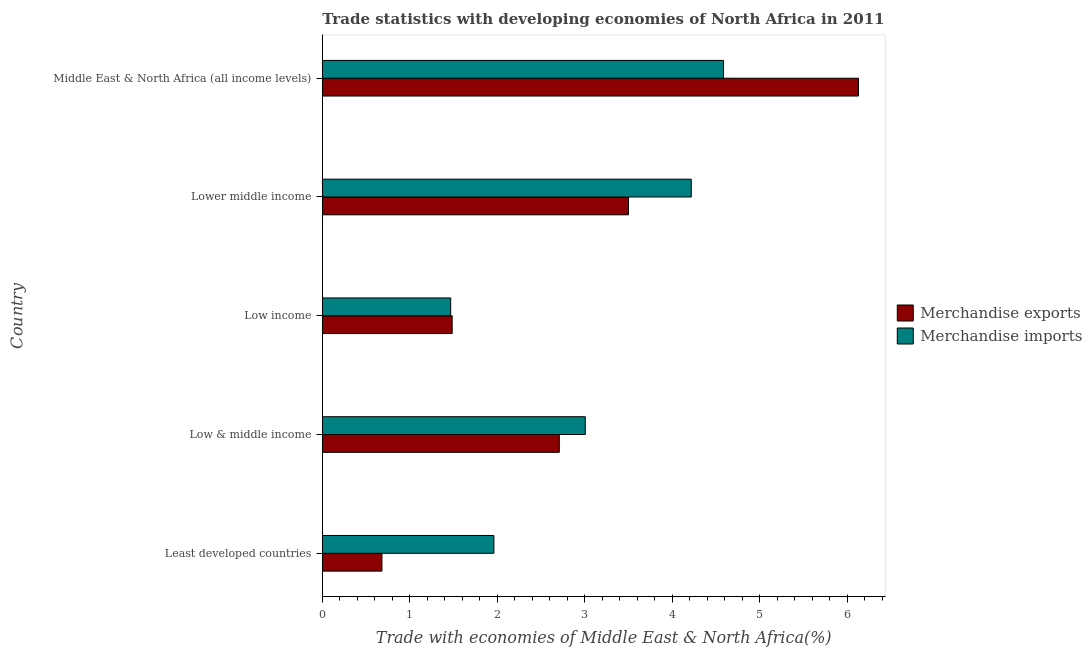How many groups of bars are there?
Ensure brevity in your answer.  5. Are the number of bars on each tick of the Y-axis equal?
Offer a terse response. Yes. How many bars are there on the 3rd tick from the top?
Your response must be concise. 2. How many bars are there on the 3rd tick from the bottom?
Your answer should be very brief. 2. What is the label of the 5th group of bars from the top?
Your answer should be compact. Least developed countries. In how many cases, is the number of bars for a given country not equal to the number of legend labels?
Provide a succinct answer. 0. What is the merchandise imports in Least developed countries?
Keep it short and to the point. 1.96. Across all countries, what is the maximum merchandise exports?
Keep it short and to the point. 6.13. Across all countries, what is the minimum merchandise imports?
Provide a succinct answer. 1.47. In which country was the merchandise exports maximum?
Offer a very short reply. Middle East & North Africa (all income levels). In which country was the merchandise exports minimum?
Your answer should be compact. Least developed countries. What is the total merchandise exports in the graph?
Give a very brief answer. 14.5. What is the difference between the merchandise imports in Least developed countries and that in Lower middle income?
Offer a terse response. -2.26. What is the difference between the merchandise imports in Low & middle income and the merchandise exports in Middle East & North Africa (all income levels)?
Your answer should be very brief. -3.12. What is the average merchandise exports per country?
Your answer should be compact. 2.9. What is the difference between the merchandise imports and merchandise exports in Low income?
Make the answer very short. -0.02. What is the ratio of the merchandise imports in Low & middle income to that in Low income?
Your response must be concise. 2.05. Is the difference between the merchandise exports in Least developed countries and Middle East & North Africa (all income levels) greater than the difference between the merchandise imports in Least developed countries and Middle East & North Africa (all income levels)?
Your answer should be very brief. No. What is the difference between the highest and the second highest merchandise imports?
Ensure brevity in your answer.  0.37. What is the difference between the highest and the lowest merchandise imports?
Offer a very short reply. 3.12. What does the 2nd bar from the bottom in Least developed countries represents?
Offer a very short reply. Merchandise imports. Are all the bars in the graph horizontal?
Your answer should be compact. Yes. What is the difference between two consecutive major ticks on the X-axis?
Provide a succinct answer. 1. How many legend labels are there?
Offer a terse response. 2. How are the legend labels stacked?
Your response must be concise. Vertical. What is the title of the graph?
Your answer should be compact. Trade statistics with developing economies of North Africa in 2011. Does "Secondary Education" appear as one of the legend labels in the graph?
Ensure brevity in your answer.  No. What is the label or title of the X-axis?
Give a very brief answer. Trade with economies of Middle East & North Africa(%). What is the label or title of the Y-axis?
Your response must be concise. Country. What is the Trade with economies of Middle East & North Africa(%) in Merchandise exports in Least developed countries?
Provide a succinct answer. 0.68. What is the Trade with economies of Middle East & North Africa(%) of Merchandise imports in Least developed countries?
Keep it short and to the point. 1.96. What is the Trade with economies of Middle East & North Africa(%) in Merchandise exports in Low & middle income?
Ensure brevity in your answer.  2.71. What is the Trade with economies of Middle East & North Africa(%) in Merchandise imports in Low & middle income?
Keep it short and to the point. 3.01. What is the Trade with economies of Middle East & North Africa(%) of Merchandise exports in Low income?
Give a very brief answer. 1.48. What is the Trade with economies of Middle East & North Africa(%) of Merchandise imports in Low income?
Your answer should be compact. 1.47. What is the Trade with economies of Middle East & North Africa(%) in Merchandise exports in Lower middle income?
Provide a succinct answer. 3.5. What is the Trade with economies of Middle East & North Africa(%) of Merchandise imports in Lower middle income?
Give a very brief answer. 4.22. What is the Trade with economies of Middle East & North Africa(%) in Merchandise exports in Middle East & North Africa (all income levels)?
Offer a terse response. 6.13. What is the Trade with economies of Middle East & North Africa(%) of Merchandise imports in Middle East & North Africa (all income levels)?
Make the answer very short. 4.59. Across all countries, what is the maximum Trade with economies of Middle East & North Africa(%) in Merchandise exports?
Your answer should be very brief. 6.13. Across all countries, what is the maximum Trade with economies of Middle East & North Africa(%) in Merchandise imports?
Offer a very short reply. 4.59. Across all countries, what is the minimum Trade with economies of Middle East & North Africa(%) of Merchandise exports?
Ensure brevity in your answer.  0.68. Across all countries, what is the minimum Trade with economies of Middle East & North Africa(%) in Merchandise imports?
Offer a terse response. 1.47. What is the total Trade with economies of Middle East & North Africa(%) in Merchandise exports in the graph?
Your answer should be very brief. 14.5. What is the total Trade with economies of Middle East & North Africa(%) in Merchandise imports in the graph?
Offer a terse response. 15.24. What is the difference between the Trade with economies of Middle East & North Africa(%) in Merchandise exports in Least developed countries and that in Low & middle income?
Keep it short and to the point. -2.03. What is the difference between the Trade with economies of Middle East & North Africa(%) of Merchandise imports in Least developed countries and that in Low & middle income?
Your answer should be compact. -1.04. What is the difference between the Trade with economies of Middle East & North Africa(%) of Merchandise exports in Least developed countries and that in Low income?
Provide a succinct answer. -0.8. What is the difference between the Trade with economies of Middle East & North Africa(%) in Merchandise imports in Least developed countries and that in Low income?
Your response must be concise. 0.49. What is the difference between the Trade with economies of Middle East & North Africa(%) of Merchandise exports in Least developed countries and that in Lower middle income?
Keep it short and to the point. -2.82. What is the difference between the Trade with economies of Middle East & North Africa(%) in Merchandise imports in Least developed countries and that in Lower middle income?
Give a very brief answer. -2.26. What is the difference between the Trade with economies of Middle East & North Africa(%) in Merchandise exports in Least developed countries and that in Middle East & North Africa (all income levels)?
Offer a terse response. -5.45. What is the difference between the Trade with economies of Middle East & North Africa(%) in Merchandise imports in Least developed countries and that in Middle East & North Africa (all income levels)?
Offer a terse response. -2.62. What is the difference between the Trade with economies of Middle East & North Africa(%) of Merchandise exports in Low & middle income and that in Low income?
Your answer should be very brief. 1.22. What is the difference between the Trade with economies of Middle East & North Africa(%) of Merchandise imports in Low & middle income and that in Low income?
Provide a succinct answer. 1.54. What is the difference between the Trade with economies of Middle East & North Africa(%) in Merchandise exports in Low & middle income and that in Lower middle income?
Keep it short and to the point. -0.79. What is the difference between the Trade with economies of Middle East & North Africa(%) of Merchandise imports in Low & middle income and that in Lower middle income?
Your response must be concise. -1.21. What is the difference between the Trade with economies of Middle East & North Africa(%) in Merchandise exports in Low & middle income and that in Middle East & North Africa (all income levels)?
Ensure brevity in your answer.  -3.42. What is the difference between the Trade with economies of Middle East & North Africa(%) in Merchandise imports in Low & middle income and that in Middle East & North Africa (all income levels)?
Offer a terse response. -1.58. What is the difference between the Trade with economies of Middle East & North Africa(%) of Merchandise exports in Low income and that in Lower middle income?
Offer a terse response. -2.02. What is the difference between the Trade with economies of Middle East & North Africa(%) of Merchandise imports in Low income and that in Lower middle income?
Ensure brevity in your answer.  -2.75. What is the difference between the Trade with economies of Middle East & North Africa(%) of Merchandise exports in Low income and that in Middle East & North Africa (all income levels)?
Ensure brevity in your answer.  -4.64. What is the difference between the Trade with economies of Middle East & North Africa(%) in Merchandise imports in Low income and that in Middle East & North Africa (all income levels)?
Your response must be concise. -3.12. What is the difference between the Trade with economies of Middle East & North Africa(%) in Merchandise exports in Lower middle income and that in Middle East & North Africa (all income levels)?
Your response must be concise. -2.63. What is the difference between the Trade with economies of Middle East & North Africa(%) in Merchandise imports in Lower middle income and that in Middle East & North Africa (all income levels)?
Give a very brief answer. -0.37. What is the difference between the Trade with economies of Middle East & North Africa(%) in Merchandise exports in Least developed countries and the Trade with economies of Middle East & North Africa(%) in Merchandise imports in Low & middle income?
Your answer should be very brief. -2.32. What is the difference between the Trade with economies of Middle East & North Africa(%) of Merchandise exports in Least developed countries and the Trade with economies of Middle East & North Africa(%) of Merchandise imports in Low income?
Offer a very short reply. -0.79. What is the difference between the Trade with economies of Middle East & North Africa(%) in Merchandise exports in Least developed countries and the Trade with economies of Middle East & North Africa(%) in Merchandise imports in Lower middle income?
Offer a very short reply. -3.54. What is the difference between the Trade with economies of Middle East & North Africa(%) in Merchandise exports in Least developed countries and the Trade with economies of Middle East & North Africa(%) in Merchandise imports in Middle East & North Africa (all income levels)?
Your answer should be very brief. -3.9. What is the difference between the Trade with economies of Middle East & North Africa(%) of Merchandise exports in Low & middle income and the Trade with economies of Middle East & North Africa(%) of Merchandise imports in Low income?
Offer a terse response. 1.24. What is the difference between the Trade with economies of Middle East & North Africa(%) in Merchandise exports in Low & middle income and the Trade with economies of Middle East & North Africa(%) in Merchandise imports in Lower middle income?
Your answer should be compact. -1.51. What is the difference between the Trade with economies of Middle East & North Africa(%) of Merchandise exports in Low & middle income and the Trade with economies of Middle East & North Africa(%) of Merchandise imports in Middle East & North Africa (all income levels)?
Offer a terse response. -1.88. What is the difference between the Trade with economies of Middle East & North Africa(%) in Merchandise exports in Low income and the Trade with economies of Middle East & North Africa(%) in Merchandise imports in Lower middle income?
Offer a terse response. -2.73. What is the difference between the Trade with economies of Middle East & North Africa(%) of Merchandise exports in Low income and the Trade with economies of Middle East & North Africa(%) of Merchandise imports in Middle East & North Africa (all income levels)?
Ensure brevity in your answer.  -3.1. What is the difference between the Trade with economies of Middle East & North Africa(%) of Merchandise exports in Lower middle income and the Trade with economies of Middle East & North Africa(%) of Merchandise imports in Middle East & North Africa (all income levels)?
Keep it short and to the point. -1.09. What is the average Trade with economies of Middle East & North Africa(%) of Merchandise exports per country?
Ensure brevity in your answer.  2.9. What is the average Trade with economies of Middle East & North Africa(%) of Merchandise imports per country?
Ensure brevity in your answer.  3.05. What is the difference between the Trade with economies of Middle East & North Africa(%) in Merchandise exports and Trade with economies of Middle East & North Africa(%) in Merchandise imports in Least developed countries?
Offer a terse response. -1.28. What is the difference between the Trade with economies of Middle East & North Africa(%) of Merchandise exports and Trade with economies of Middle East & North Africa(%) of Merchandise imports in Low & middle income?
Ensure brevity in your answer.  -0.3. What is the difference between the Trade with economies of Middle East & North Africa(%) in Merchandise exports and Trade with economies of Middle East & North Africa(%) in Merchandise imports in Low income?
Your response must be concise. 0.02. What is the difference between the Trade with economies of Middle East & North Africa(%) of Merchandise exports and Trade with economies of Middle East & North Africa(%) of Merchandise imports in Lower middle income?
Your answer should be compact. -0.72. What is the difference between the Trade with economies of Middle East & North Africa(%) of Merchandise exports and Trade with economies of Middle East & North Africa(%) of Merchandise imports in Middle East & North Africa (all income levels)?
Keep it short and to the point. 1.54. What is the ratio of the Trade with economies of Middle East & North Africa(%) in Merchandise exports in Least developed countries to that in Low & middle income?
Ensure brevity in your answer.  0.25. What is the ratio of the Trade with economies of Middle East & North Africa(%) in Merchandise imports in Least developed countries to that in Low & middle income?
Make the answer very short. 0.65. What is the ratio of the Trade with economies of Middle East & North Africa(%) of Merchandise exports in Least developed countries to that in Low income?
Make the answer very short. 0.46. What is the ratio of the Trade with economies of Middle East & North Africa(%) of Merchandise imports in Least developed countries to that in Low income?
Offer a very short reply. 1.34. What is the ratio of the Trade with economies of Middle East & North Africa(%) in Merchandise exports in Least developed countries to that in Lower middle income?
Your answer should be very brief. 0.19. What is the ratio of the Trade with economies of Middle East & North Africa(%) of Merchandise imports in Least developed countries to that in Lower middle income?
Offer a very short reply. 0.47. What is the ratio of the Trade with economies of Middle East & North Africa(%) in Merchandise exports in Least developed countries to that in Middle East & North Africa (all income levels)?
Provide a succinct answer. 0.11. What is the ratio of the Trade with economies of Middle East & North Africa(%) of Merchandise imports in Least developed countries to that in Middle East & North Africa (all income levels)?
Your response must be concise. 0.43. What is the ratio of the Trade with economies of Middle East & North Africa(%) in Merchandise exports in Low & middle income to that in Low income?
Make the answer very short. 1.83. What is the ratio of the Trade with economies of Middle East & North Africa(%) in Merchandise imports in Low & middle income to that in Low income?
Your response must be concise. 2.05. What is the ratio of the Trade with economies of Middle East & North Africa(%) in Merchandise exports in Low & middle income to that in Lower middle income?
Offer a terse response. 0.77. What is the ratio of the Trade with economies of Middle East & North Africa(%) in Merchandise imports in Low & middle income to that in Lower middle income?
Your answer should be very brief. 0.71. What is the ratio of the Trade with economies of Middle East & North Africa(%) of Merchandise exports in Low & middle income to that in Middle East & North Africa (all income levels)?
Provide a succinct answer. 0.44. What is the ratio of the Trade with economies of Middle East & North Africa(%) in Merchandise imports in Low & middle income to that in Middle East & North Africa (all income levels)?
Offer a very short reply. 0.66. What is the ratio of the Trade with economies of Middle East & North Africa(%) of Merchandise exports in Low income to that in Lower middle income?
Provide a short and direct response. 0.42. What is the ratio of the Trade with economies of Middle East & North Africa(%) of Merchandise imports in Low income to that in Lower middle income?
Provide a succinct answer. 0.35. What is the ratio of the Trade with economies of Middle East & North Africa(%) of Merchandise exports in Low income to that in Middle East & North Africa (all income levels)?
Give a very brief answer. 0.24. What is the ratio of the Trade with economies of Middle East & North Africa(%) of Merchandise imports in Low income to that in Middle East & North Africa (all income levels)?
Give a very brief answer. 0.32. What is the ratio of the Trade with economies of Middle East & North Africa(%) of Merchandise exports in Lower middle income to that in Middle East & North Africa (all income levels)?
Offer a terse response. 0.57. What is the ratio of the Trade with economies of Middle East & North Africa(%) of Merchandise imports in Lower middle income to that in Middle East & North Africa (all income levels)?
Make the answer very short. 0.92. What is the difference between the highest and the second highest Trade with economies of Middle East & North Africa(%) of Merchandise exports?
Keep it short and to the point. 2.63. What is the difference between the highest and the second highest Trade with economies of Middle East & North Africa(%) in Merchandise imports?
Give a very brief answer. 0.37. What is the difference between the highest and the lowest Trade with economies of Middle East & North Africa(%) of Merchandise exports?
Offer a terse response. 5.45. What is the difference between the highest and the lowest Trade with economies of Middle East & North Africa(%) in Merchandise imports?
Offer a very short reply. 3.12. 